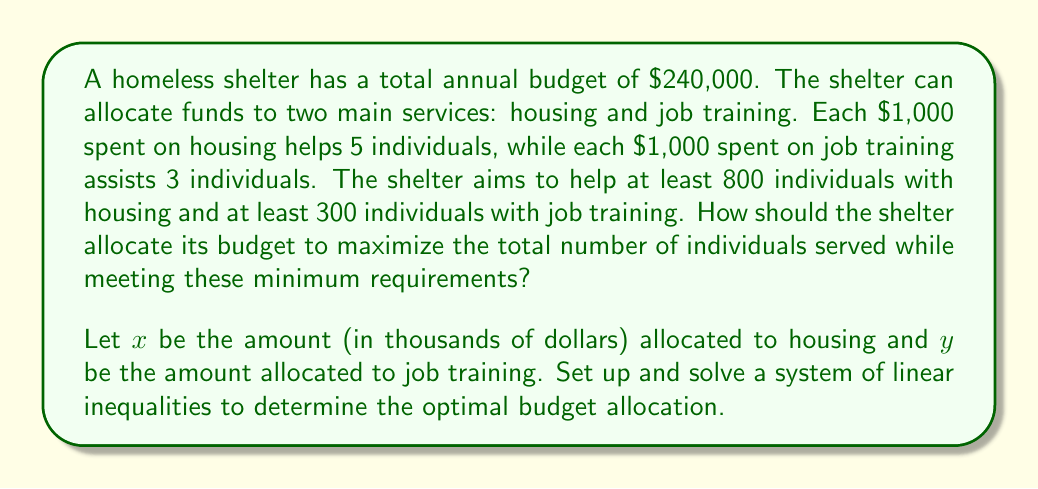Can you solve this math problem? Let's approach this step-by-step:

1) First, we need to set up our constraints:

   - Budget constraint: $x + y = 240$ (total budget is $240,000)
   - Housing constraint: $5x \geq 800$ (at least 800 individuals for housing)
   - Job training constraint: $3y \geq 300$ (at least 300 individuals for job training)
   - Non-negativity: $x \geq 0, y \geq 0$

2) Simplify the constraints:

   - $x + y = 240$
   - $x \geq 160$
   - $y \geq 100$

3) Our objective is to maximize $5x + 3y$ (total individuals served)

4) We can solve this graphically or using the corner point method. Let's use the corner point method:

   Potential corner points:
   (160, 100), (160, 80), (140, 100)

5) Evaluate the objective function at each point:

   (160, 100): $5(160) + 3(100) = 1100$
   (160, 80): $5(160) + 3(80) = 1040$
   (140, 100): $5(140) + 3(100) = 1000$

6) The maximum value occurs at (160, 100)

Therefore, the optimal allocation is $160,000 for housing and $100,000 for job training, serving a total of 1100 individuals.
Answer: $160,000 for housing, $100,000 for job training 